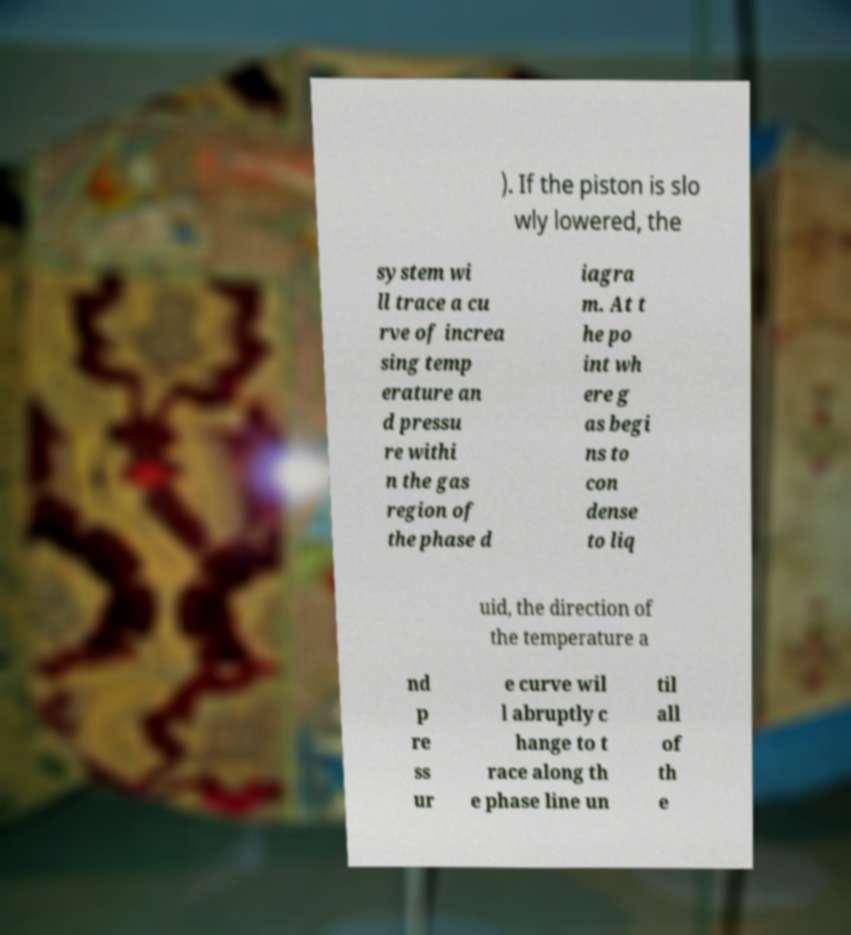Can you accurately transcribe the text from the provided image for me? ). If the piston is slo wly lowered, the system wi ll trace a cu rve of increa sing temp erature an d pressu re withi n the gas region of the phase d iagra m. At t he po int wh ere g as begi ns to con dense to liq uid, the direction of the temperature a nd p re ss ur e curve wil l abruptly c hange to t race along th e phase line un til all of th e 